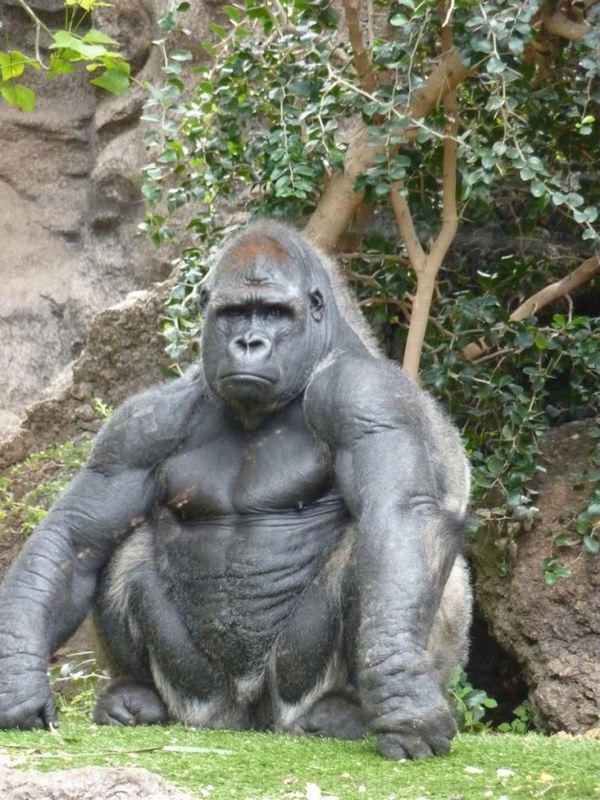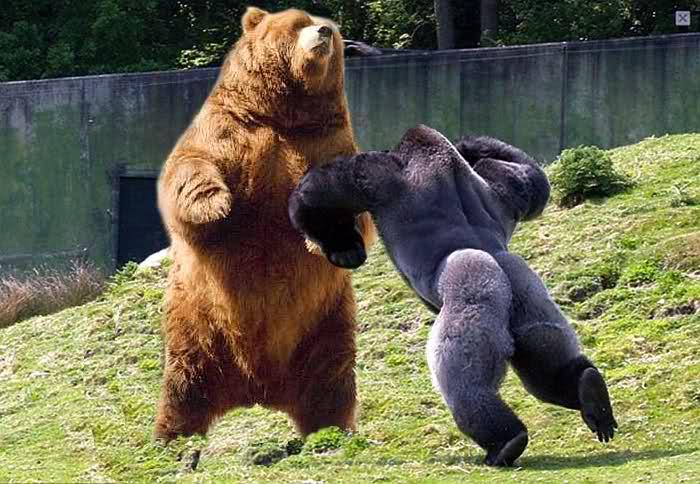The first image is the image on the left, the second image is the image on the right. Given the left and right images, does the statement "In one of the images there is a baby gorilla near at least one adult gorilla." hold true? Answer yes or no. No. 